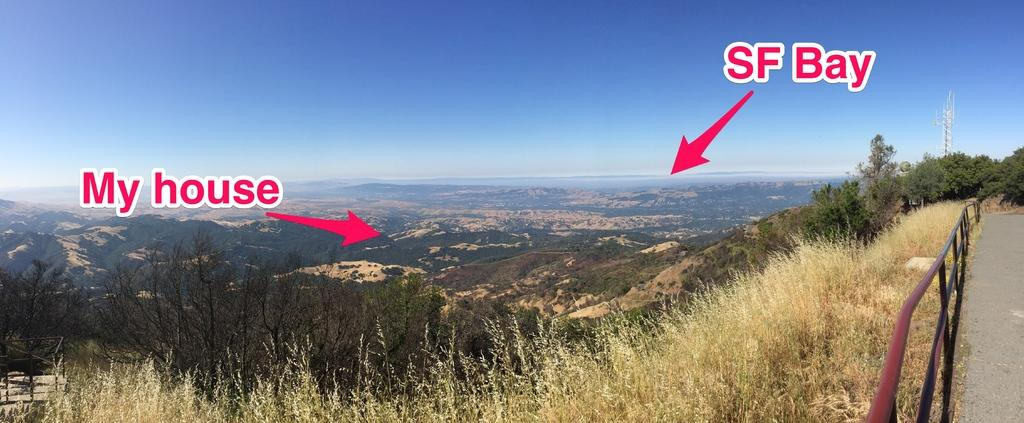Provide a one-sentence caption for the provided image. My house is a short distance away from San Francisco bay. 